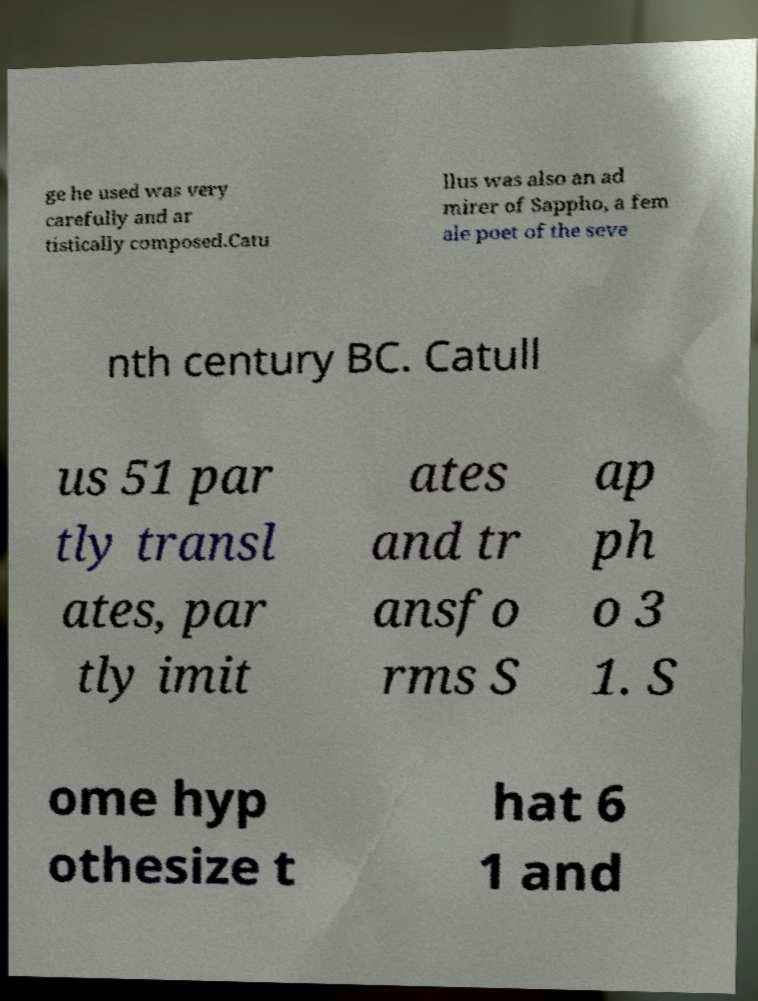Can you read and provide the text displayed in the image?This photo seems to have some interesting text. Can you extract and type it out for me? ge he used was very carefully and ar tistically composed.Catu llus was also an ad mirer of Sappho, a fem ale poet of the seve nth century BC. Catull us 51 par tly transl ates, par tly imit ates and tr ansfo rms S ap ph o 3 1. S ome hyp othesize t hat 6 1 and 